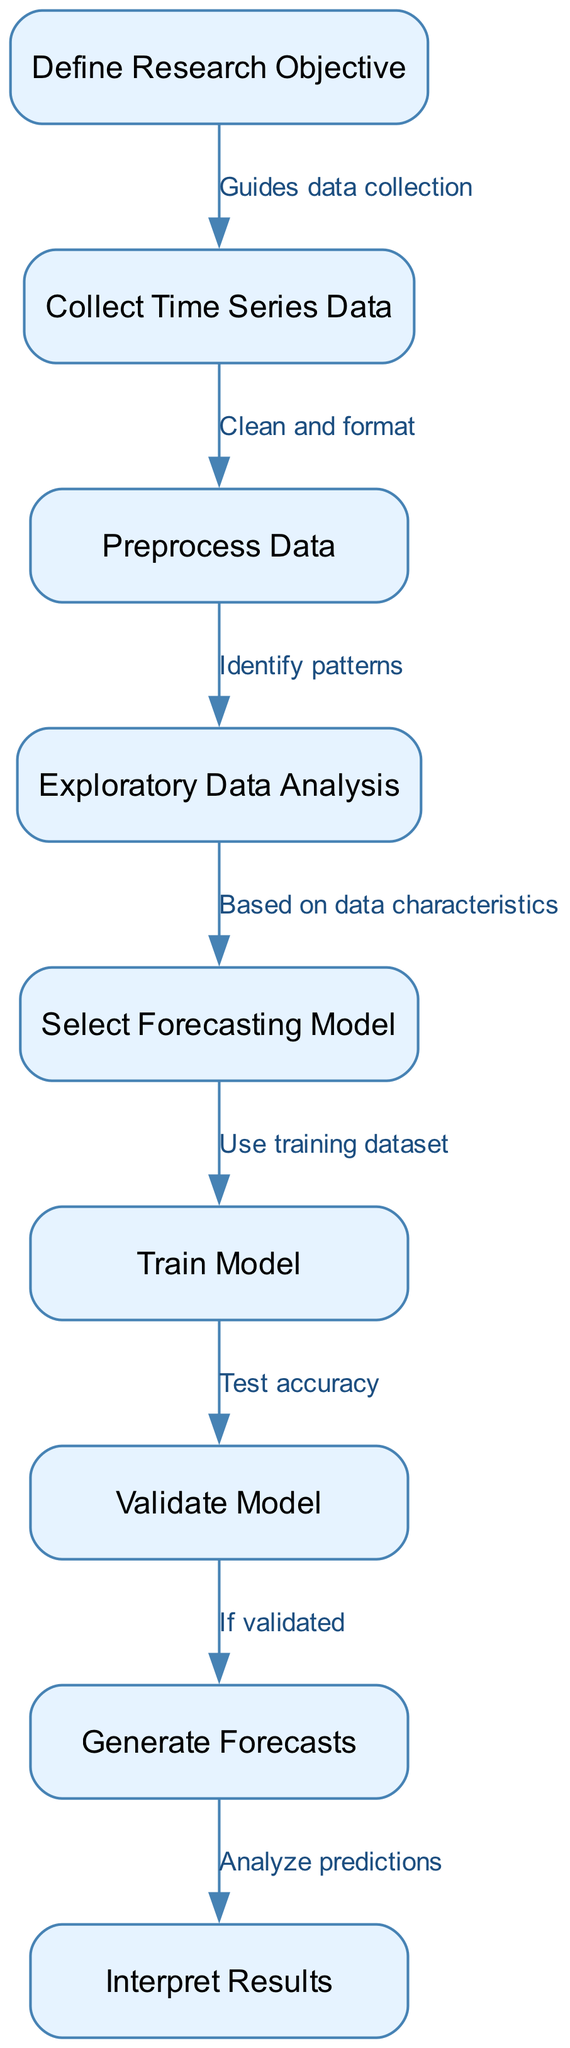What is the first step in the process? The diagram starts with the node labeled "Define Research Objective," indicating that this is the initial step involved in developing the forecasting model.
Answer: Define Research Objective How many nodes are present in the diagram? By counting the nodes listed in the diagram, we see there are nine distinct processes or steps outlined.
Answer: 9 What step follows "Preprocess Data"? According to the diagram, the step that comes immediately after "Preprocess Data" is "Exploratory Data Analysis." This can be confirmed by following the directed edge from the preprocessing step.
Answer: Exploratory Data Analysis What guides the data collection process? The flow chart connects "Define Research Objective" to "Collect Time Series Data" with a note stating "Guides data collection," indicating that the research objective determines how data will be sourced.
Answer: Define Research Objective What is the last step in the forecasting model process? The final node in the diagram is "Interpret Results," which signifies the last action taken after generating forecasts.
Answer: Interpret Results What is required before generating forecasts? Before reaching the step "Generate Forecasts," the model must be validated, as indicated by the directed edge labeled "If validated." This ensures the accuracy of the model before producing forecasts.
Answer: Validate Model Which step incorporates identifying patterns in data? The step that focuses on identifying patterns is "Exploratory Data Analysis," as indicated by the arrow leading from "Preprocess Data" pointing to this specific node.
Answer: Exploratory Data Analysis Which steps are involved in model training? The steps involved in model training are "Select Forecasting Model" and "Train Model." First, the model is selected based on data characteristics, followed by training it with a designated dataset.
Answer: Select Forecasting Model and Train Model What relation does "Train Model" have with "Validate Model"? There is a direct relationship where "Train Model" leads to "Validate Model" with the description "Test accuracy," indicating that after the model training, its accuracy is assessed in the validation phase.
Answer: Test accuracy 